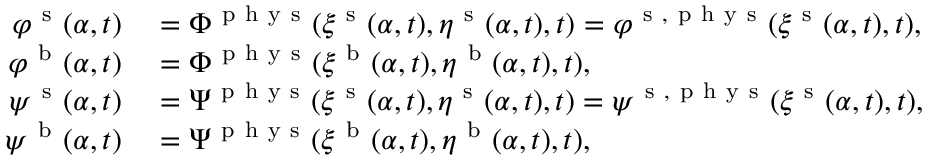Convert formula to latex. <formula><loc_0><loc_0><loc_500><loc_500>\begin{array} { r l } { \varphi ^ { s } ( \alpha , t ) } & = \Phi ^ { p h y s } ( \xi ^ { s } ( \alpha , t ) , \eta ^ { s } ( \alpha , t ) , t ) = \varphi ^ { s , p h y s } ( \xi ^ { s } ( \alpha , t ) , t ) , } \\ { \varphi ^ { b } ( \alpha , t ) } & = \Phi ^ { p h y s } ( \xi ^ { b } ( \alpha , t ) , \eta ^ { b } ( \alpha , t ) , t ) , } \\ { \psi ^ { s } ( \alpha , t ) } & = \Psi ^ { p h y s } ( \xi ^ { s } ( \alpha , t ) , \eta ^ { s } ( \alpha , t ) , t ) = \psi ^ { s , p h y s } ( \xi ^ { s } ( \alpha , t ) , t ) , } \\ { \psi ^ { b } ( \alpha , t ) } & = \Psi ^ { p h y s } ( \xi ^ { b } ( \alpha , t ) , \eta ^ { b } ( \alpha , t ) , t ) , } \end{array}</formula> 